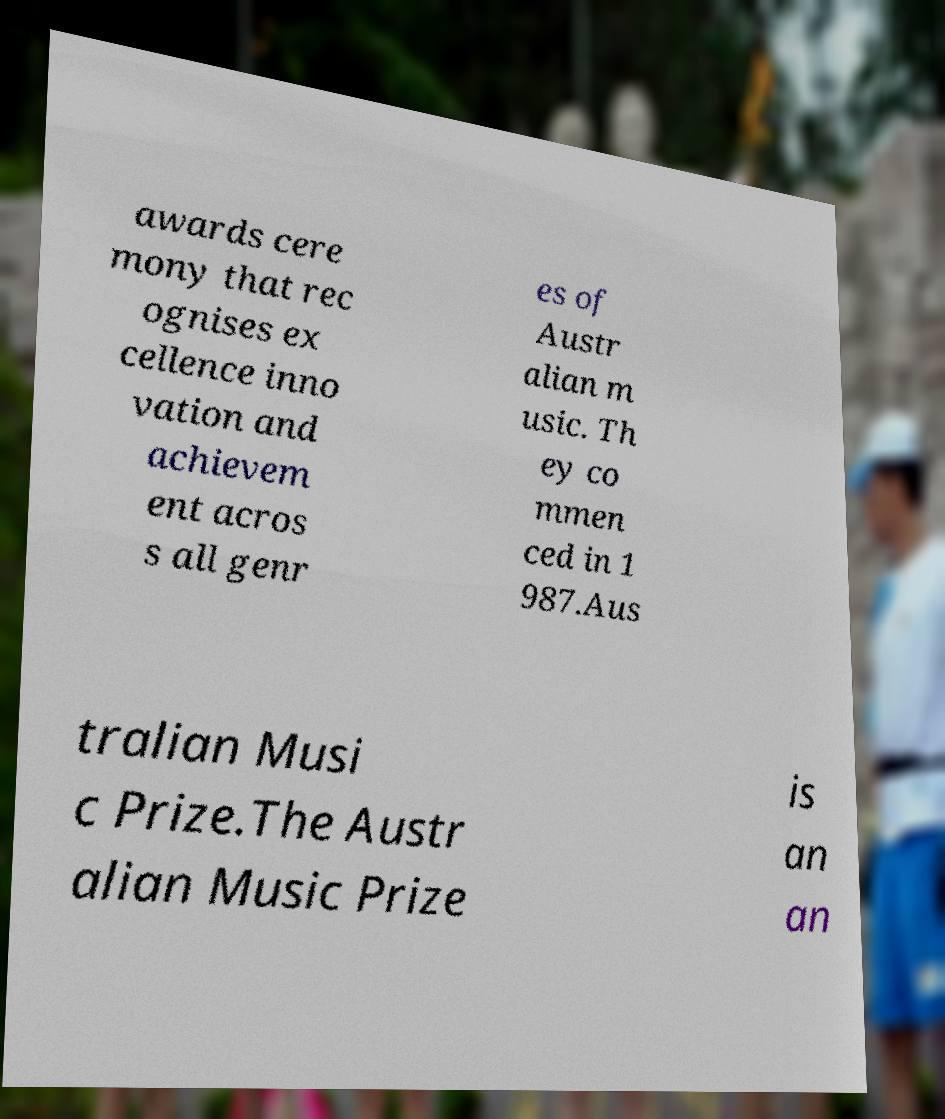Could you assist in decoding the text presented in this image and type it out clearly? awards cere mony that rec ognises ex cellence inno vation and achievem ent acros s all genr es of Austr alian m usic. Th ey co mmen ced in 1 987.Aus tralian Musi c Prize.The Austr alian Music Prize is an an 